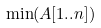<formula> <loc_0><loc_0><loc_500><loc_500>\min ( A [ 1 . . n ] )</formula> 